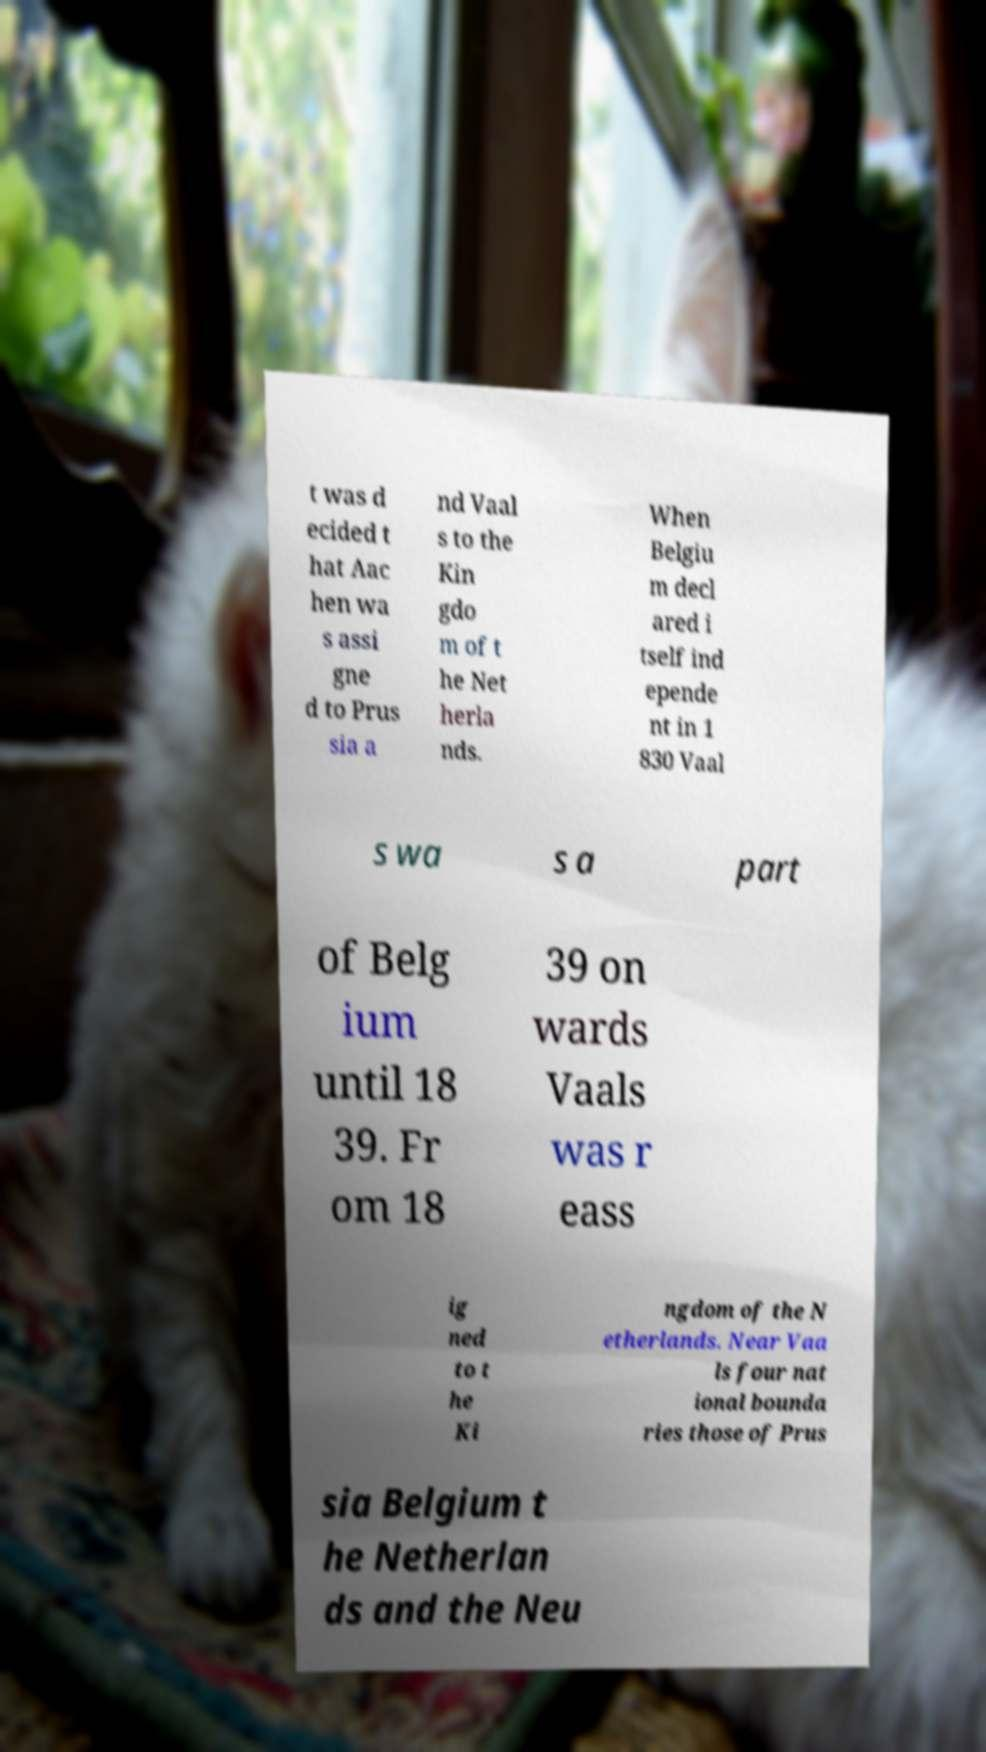I need the written content from this picture converted into text. Can you do that? t was d ecided t hat Aac hen wa s assi gne d to Prus sia a nd Vaal s to the Kin gdo m of t he Net herla nds. When Belgiu m decl ared i tself ind epende nt in 1 830 Vaal s wa s a part of Belg ium until 18 39. Fr om 18 39 on wards Vaals was r eass ig ned to t he Ki ngdom of the N etherlands. Near Vaa ls four nat ional bounda ries those of Prus sia Belgium t he Netherlan ds and the Neu 